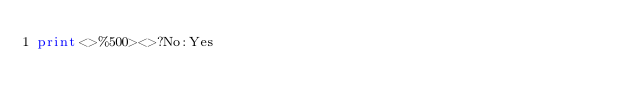Convert code to text. <code><loc_0><loc_0><loc_500><loc_500><_Perl_>print<>%500><>?No:Yes</code> 